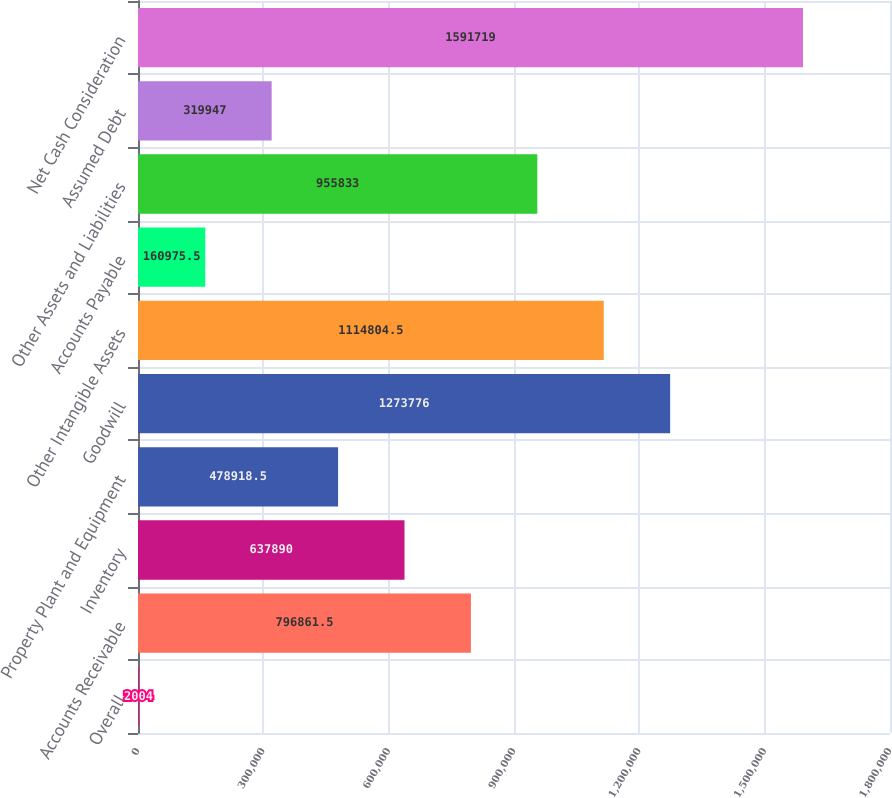<chart> <loc_0><loc_0><loc_500><loc_500><bar_chart><fcel>Overall<fcel>Accounts Receivable<fcel>Inventory<fcel>Property Plant and Equipment<fcel>Goodwill<fcel>Other Intangible Assets<fcel>Accounts Payable<fcel>Other Assets and Liabilities<fcel>Assumed Debt<fcel>Net Cash Consideration<nl><fcel>2004<fcel>796862<fcel>637890<fcel>478918<fcel>1.27378e+06<fcel>1.1148e+06<fcel>160976<fcel>955833<fcel>319947<fcel>1.59172e+06<nl></chart> 